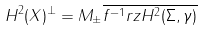<formula> <loc_0><loc_0><loc_500><loc_500>H ^ { 2 } ( X ) ^ { \perp } = M _ { \pm } \overline { f ^ { - 1 } r z H ^ { 2 } ( \Sigma , \gamma ) }</formula> 